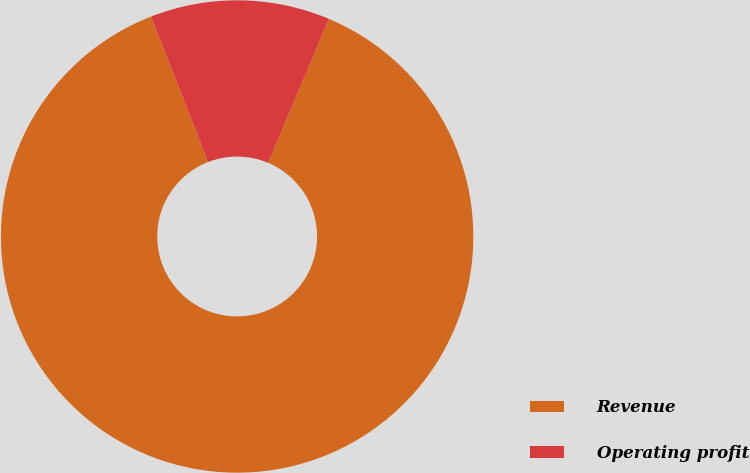Convert chart to OTSL. <chart><loc_0><loc_0><loc_500><loc_500><pie_chart><fcel>Revenue<fcel>Operating profit<nl><fcel>87.71%<fcel>12.29%<nl></chart> 